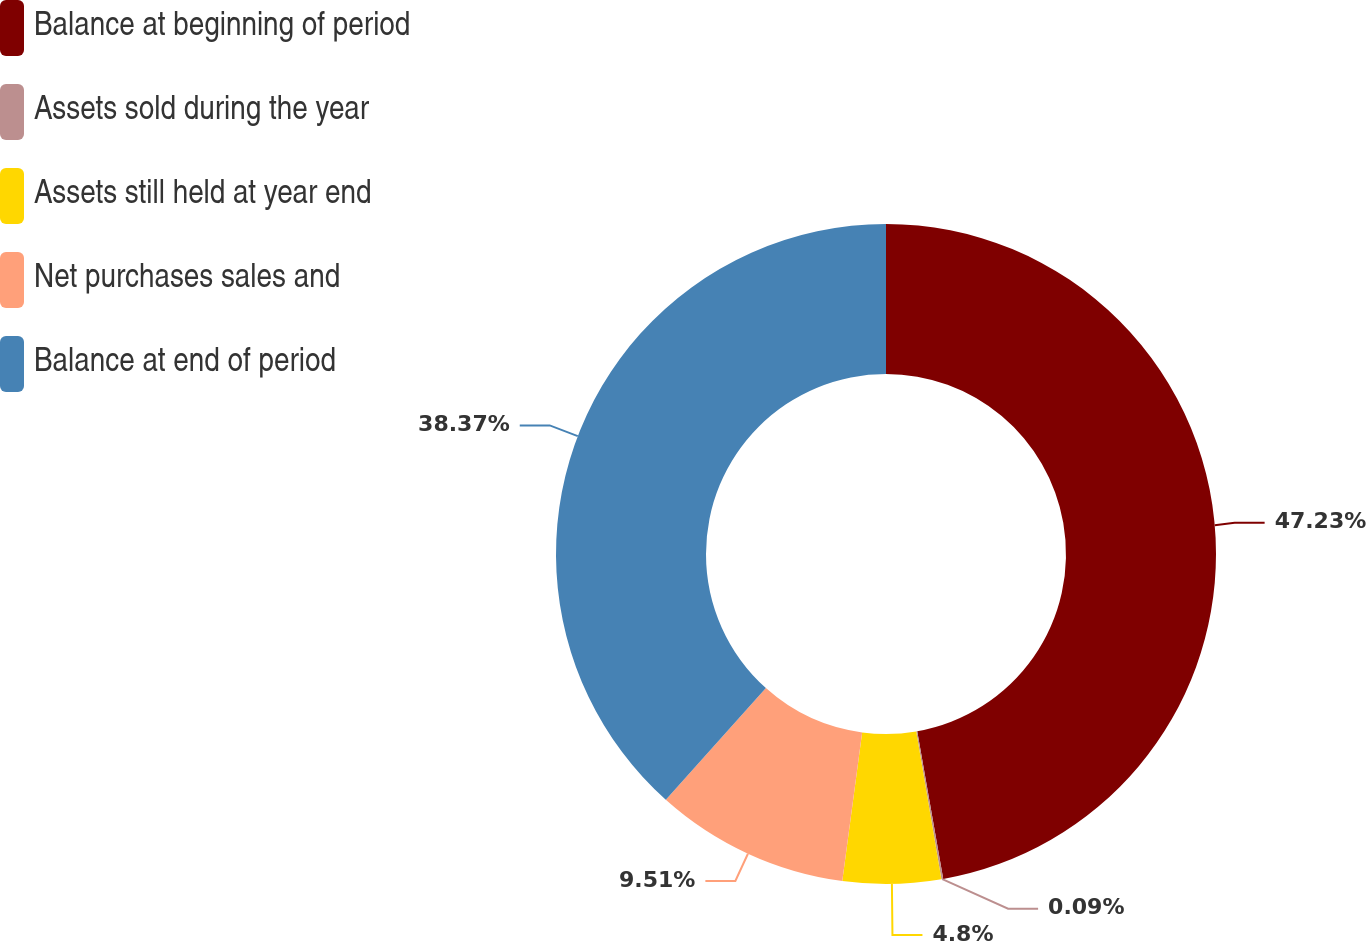Convert chart to OTSL. <chart><loc_0><loc_0><loc_500><loc_500><pie_chart><fcel>Balance at beginning of period<fcel>Assets sold during the year<fcel>Assets still held at year end<fcel>Net purchases sales and<fcel>Balance at end of period<nl><fcel>47.22%<fcel>0.09%<fcel>4.8%<fcel>9.51%<fcel>38.37%<nl></chart> 